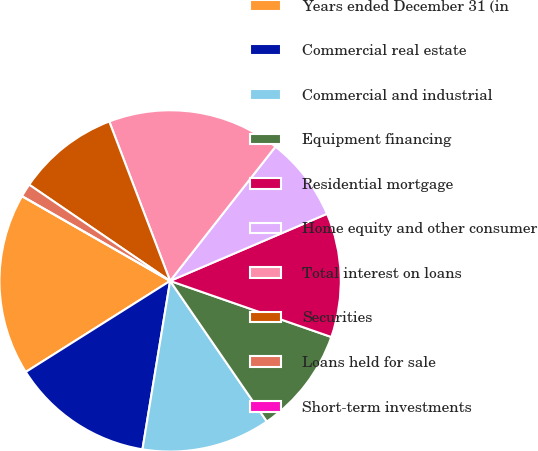<chart> <loc_0><loc_0><loc_500><loc_500><pie_chart><fcel>Years ended December 31 (in<fcel>Commercial real estate<fcel>Commercial and industrial<fcel>Equipment financing<fcel>Residential mortgage<fcel>Home equity and other consumer<fcel>Total interest on loans<fcel>Securities<fcel>Loans held for sale<fcel>Short-term investments<nl><fcel>17.23%<fcel>13.45%<fcel>12.18%<fcel>10.08%<fcel>11.76%<fcel>7.98%<fcel>16.39%<fcel>9.66%<fcel>1.26%<fcel>0.0%<nl></chart> 